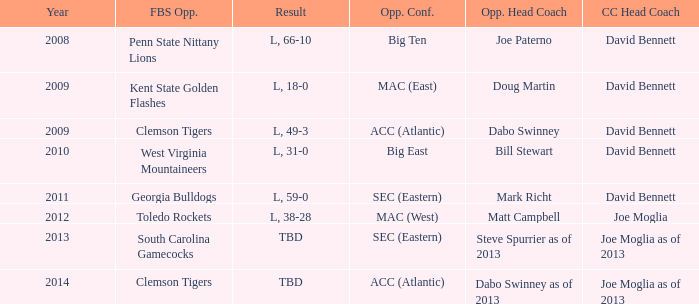Who was the coastal Carolina head coach in 2013? Joe Moglia as of 2013. 